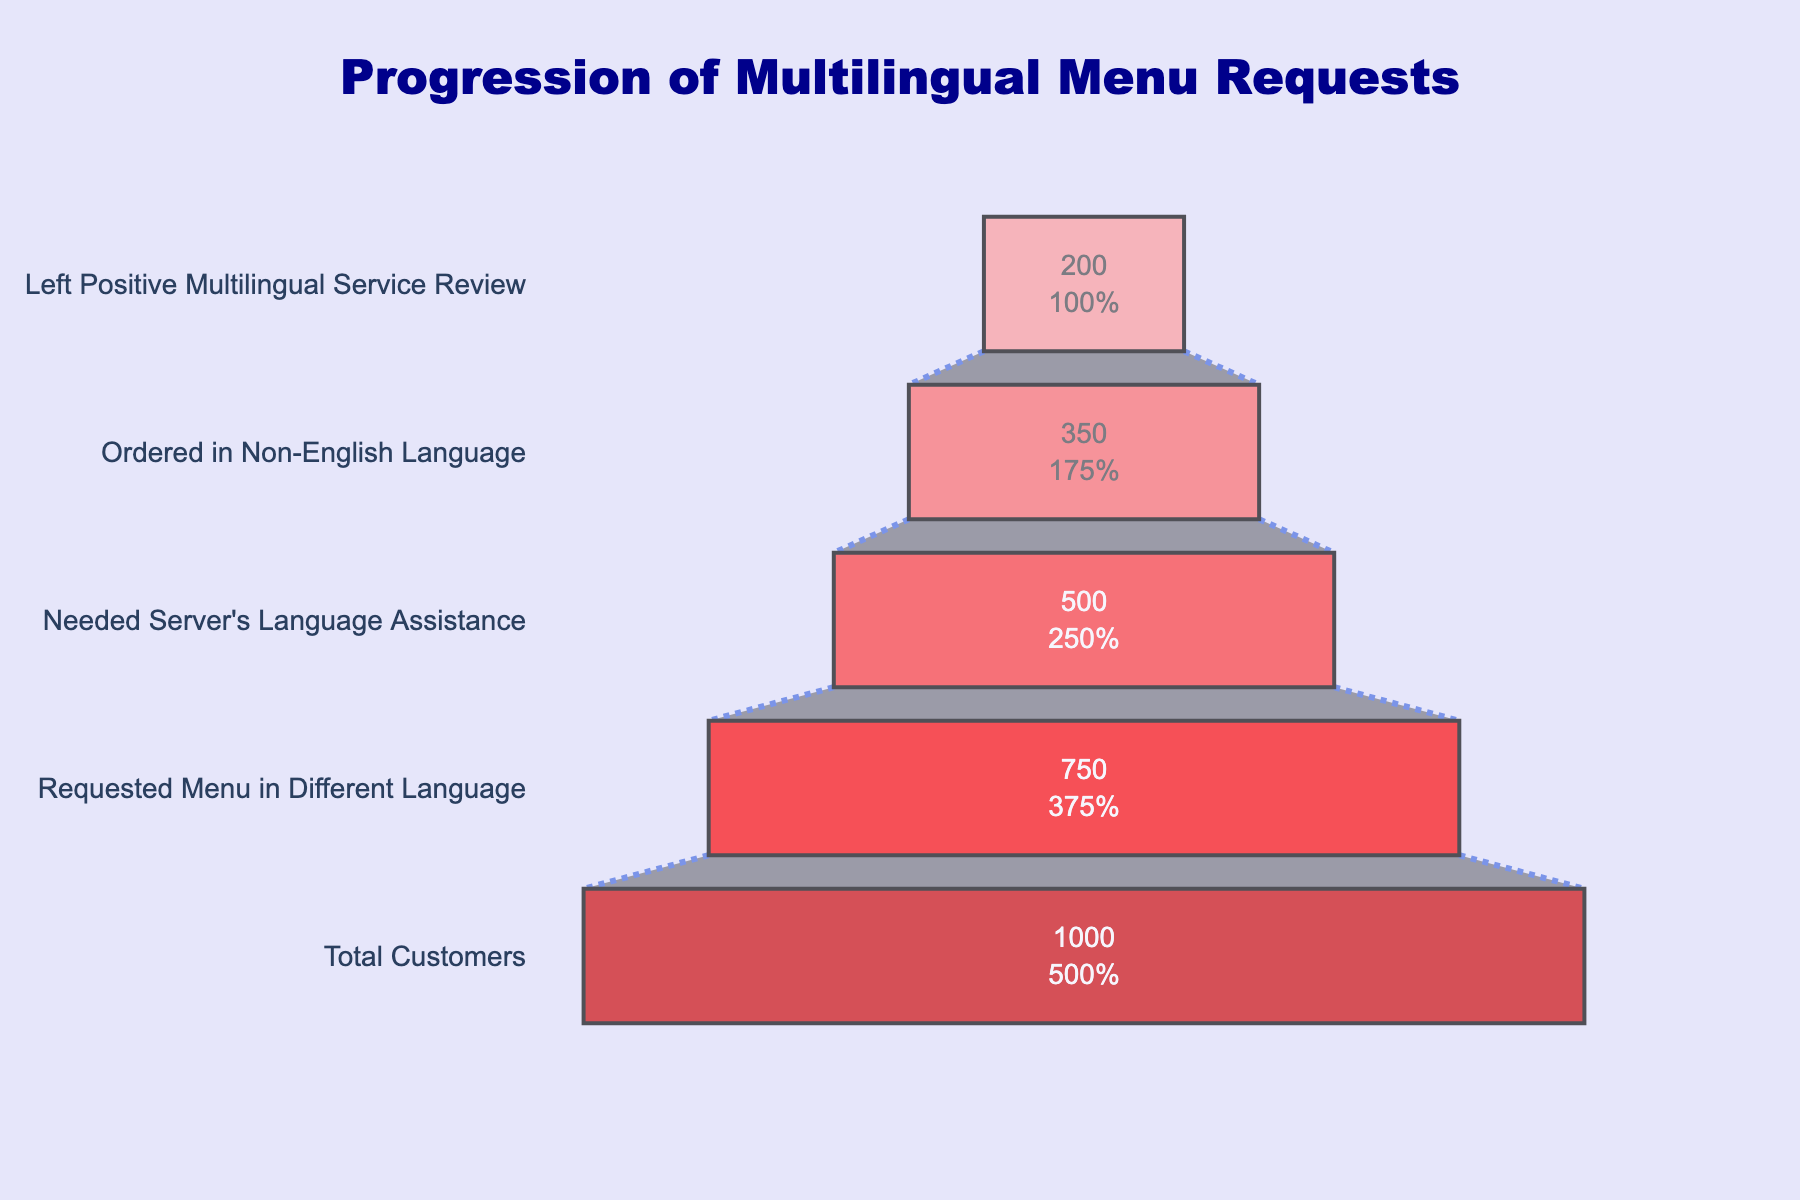What's the title of the funnel chart? The title of the funnel chart is displayed prominently at the top of the chart. It describes the main focus of the chart, which is the progression of multilingual menu requests.
Answer: Progression of Multilingual Menu Requests How many stages are there in the funnel chart? The funnel chart consists of distinct segments, each representing a different stage in the process. By counting these segments from top to bottom, you can determine the number of stages.
Answer: 5 What's the number of customers who left positive multilingual service reviews? The funnel chart displays the number of customers at each stage. By looking at the final stage at the bottom of the chart, you can find the number of customers who left positive multilingual service reviews.
Answer: 200 How many customers needed server's language assistance? The funnel chart includes a stage for the number of customers who needed server's language assistance. By referring to that specific stage, you find the number of customers indicated.
Answer: 500 What percentage of total customers requested a menu in a different language? The 'Requested Menu in Different Language' stage has 750 customers, and the 'Total Customers' stage at the top has 1000 customers. The percentage is calculated by (750 / 1000) * 100.
Answer: 75% Which stage has the largest drop in the number of customers? To determine which stage has the largest drop, compare the customer numbers between subsequent stages. The largest difference indicates the stage with the highest drop.
Answer: Requested Menu in Different Language (250) How many customers ordered in a non-English language but did not leave a positive review? The number of customers who ordered in a non-English language is 350, and those who left a positive review are 200. Subtract the latter from the former to find the number of customers who did not leave a positive review.
Answer: 150 What's the difference in the number of customers between those who requested a multilingual menu and those who left a positive review? The number of customers who requested a multilingual menu is 750, and those who left a positive review are 200. Find the difference by subtracting 200 from 750.
Answer: 550 Is the number of customers who ordered in a non-English language greater than those who needed server's language assistance? Compare the customer numbers: 350 for those who ordered in a non-English language and 500 for those who needed server's language assistance. Determine whether the former is greater than the latter.
Answer: No 